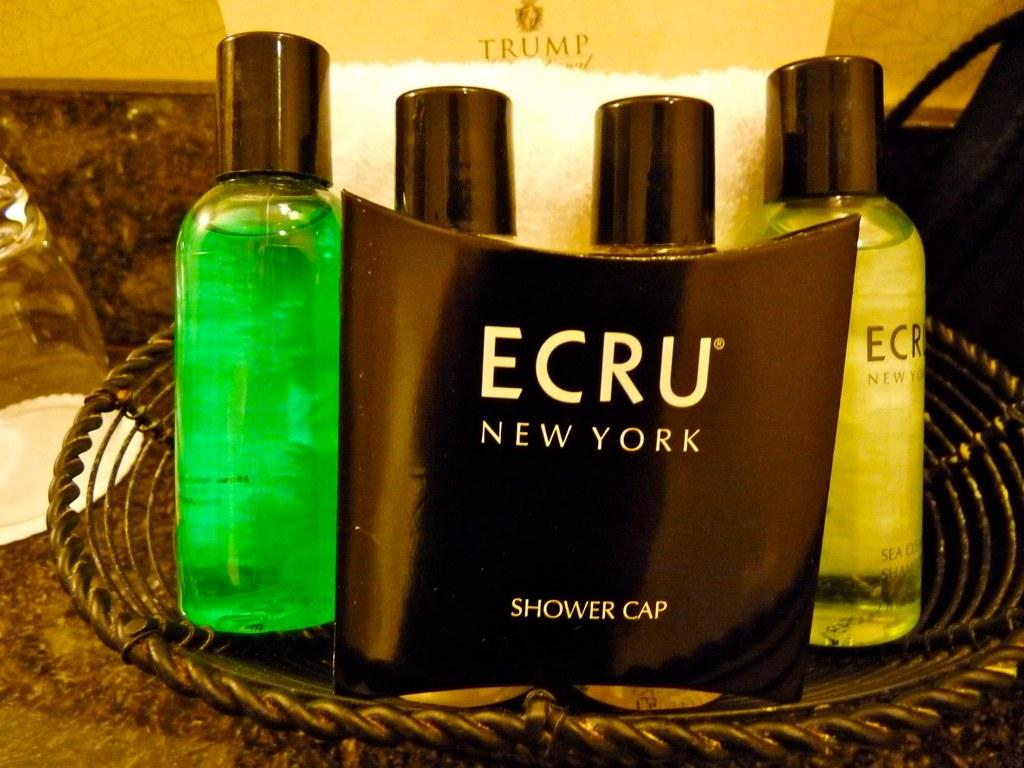<image>
Provide a brief description of the given image. A basket of toiletries is from the Trump hotel. 